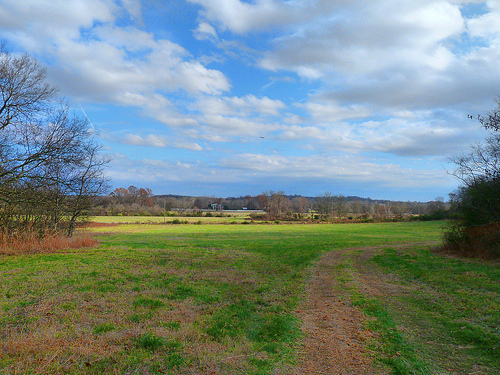<image>
Can you confirm if the cloud is above the tree? Yes. The cloud is positioned above the tree in the vertical space, higher up in the scene. 